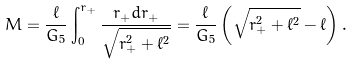Convert formula to latex. <formula><loc_0><loc_0><loc_500><loc_500>M = \frac { \ell } { G _ { 5 } } \int ^ { r _ { + } } _ { 0 } \frac { r _ { + } d r _ { + } } { \sqrt { r _ { + } ^ { 2 } + \ell ^ { 2 } } } = \frac { \ell } { G _ { 5 } } \left ( \sqrt { r _ { + } ^ { 2 } + \ell ^ { 2 } } - \ell \right ) .</formula> 